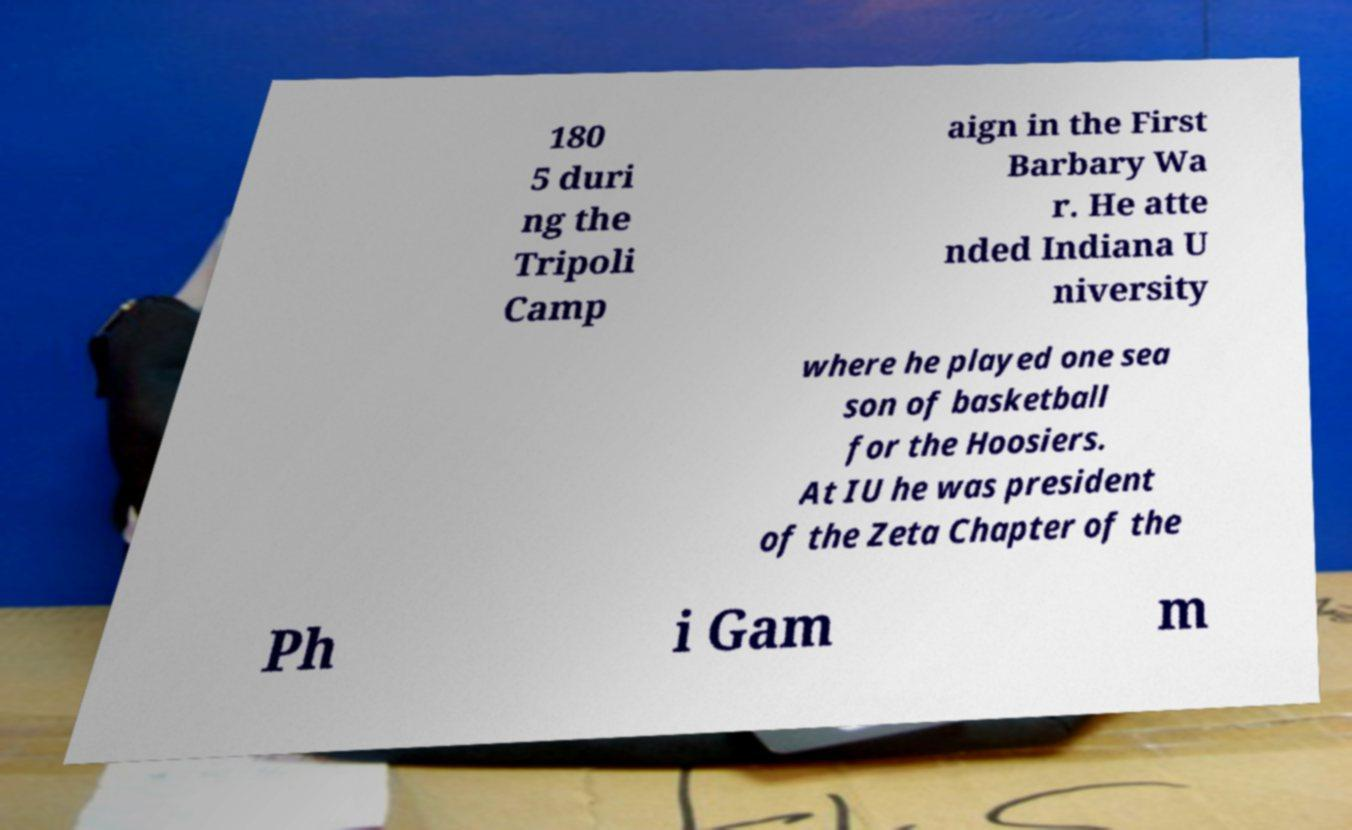For documentation purposes, I need the text within this image transcribed. Could you provide that? 180 5 duri ng the Tripoli Camp aign in the First Barbary Wa r. He atte nded Indiana U niversity where he played one sea son of basketball for the Hoosiers. At IU he was president of the Zeta Chapter of the Ph i Gam m 